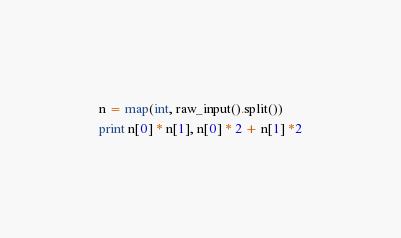<code> <loc_0><loc_0><loc_500><loc_500><_Python_>n = map(int, raw_input().split())
print n[0] * n[1], n[0] * 2 + n[1] *2</code> 